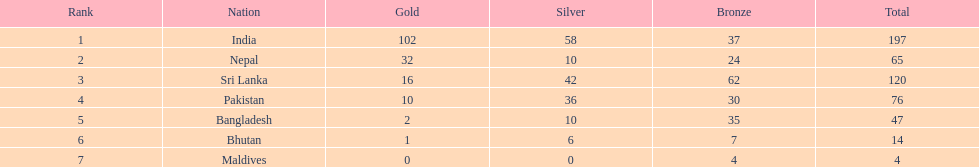Would you mind parsing the complete table? {'header': ['Rank', 'Nation', 'Gold', 'Silver', 'Bronze', 'Total'], 'rows': [['1', 'India', '102', '58', '37', '197'], ['2', 'Nepal', '32', '10', '24', '65'], ['3', 'Sri Lanka', '16', '42', '62', '120'], ['4', 'Pakistan', '10', '36', '30', '76'], ['5', 'Bangladesh', '2', '10', '35', '47'], ['6', 'Bhutan', '1', '6', '7', '14'], ['7', 'Maldives', '0', '0', '4', '4']]} What is the difference between the nation with the most medals and the nation with the least amount of medals? 193. 